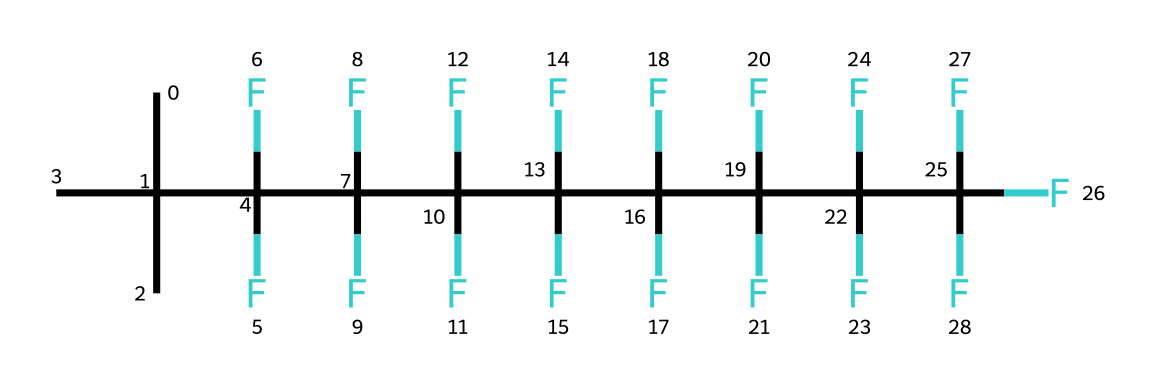How many carbon atoms are present in this chemical? The structure begins with 'C(C)(C)' indicating that there are three carbon atoms in the branched chain. The remaining parts of the molecule consist of additional carbon atoms connected in a linear chain. Counting a total of 12 carbons gives 12 carbon atoms in total.
Answer: 12 What type of chemical is this? The presence of several fluorine atoms attached to carbon suggests that it is a fluorinated compound. Specifically, the chain ends in fluorinated carbons, making it a perfluorinated compound.
Answer: perfluorinated How many fluorine atoms are there in this chemical? The SMILES representation has multiple '(F)' groupings following several carbon atoms, indicating there are 21 fluorine atoms present. Each instance of '(F)' contributes one fluorine atom to the total count.
Answer: 21 Does this chemical likely have hydrophobic properties? The extensive presence of fluorine throughout the carbon chain provides strong hydrophobic characteristics, as fluorinated compounds are known for their water-repellent behavior.
Answer: yes Is this chemical a gas or a liquid at room temperature? Given the high molecular weight and structure comprising predominantly carbon and fluorine, this compound is certainly a liquid at room temperature.
Answer: liquid What is the longest carbon chain in this chemical? After examining the structure, the longest continuous chain of carbon atoms can be found by identifying those connected in a sequence without branching. Counting those atoms reveals that the longest chain contains 12 carbons.
Answer: 12 